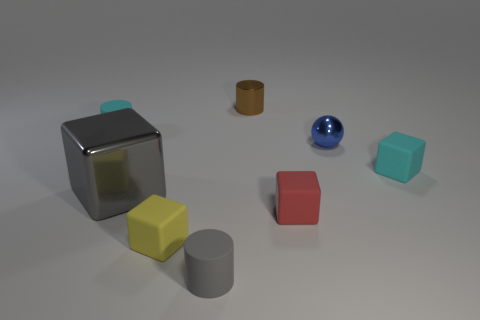Subtract 1 cubes. How many cubes are left? 3 Add 1 gray blocks. How many objects exist? 9 Subtract all brown cubes. Subtract all yellow spheres. How many cubes are left? 4 Subtract all cylinders. How many objects are left? 5 Add 1 gray shiny things. How many gray shiny things are left? 2 Add 5 gray metallic blocks. How many gray metallic blocks exist? 6 Subtract 0 blue cylinders. How many objects are left? 8 Subtract all rubber objects. Subtract all small brown objects. How many objects are left? 2 